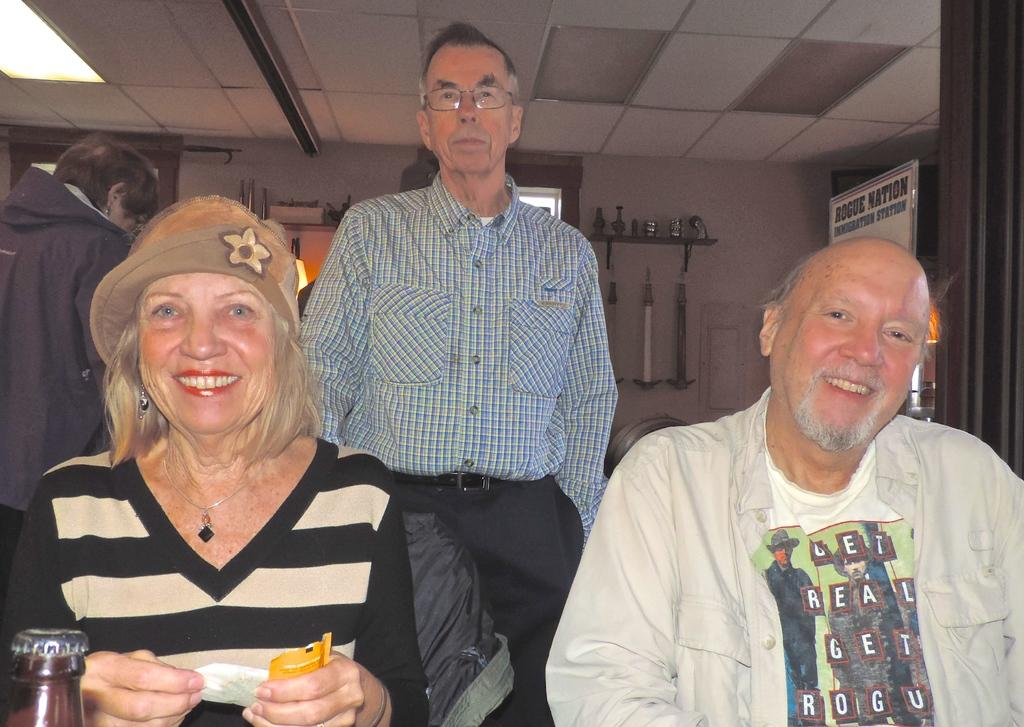<image>
Share a concise interpretation of the image provided. A man sitting next to a woman has a shirt that reads "get real, get rogue" 